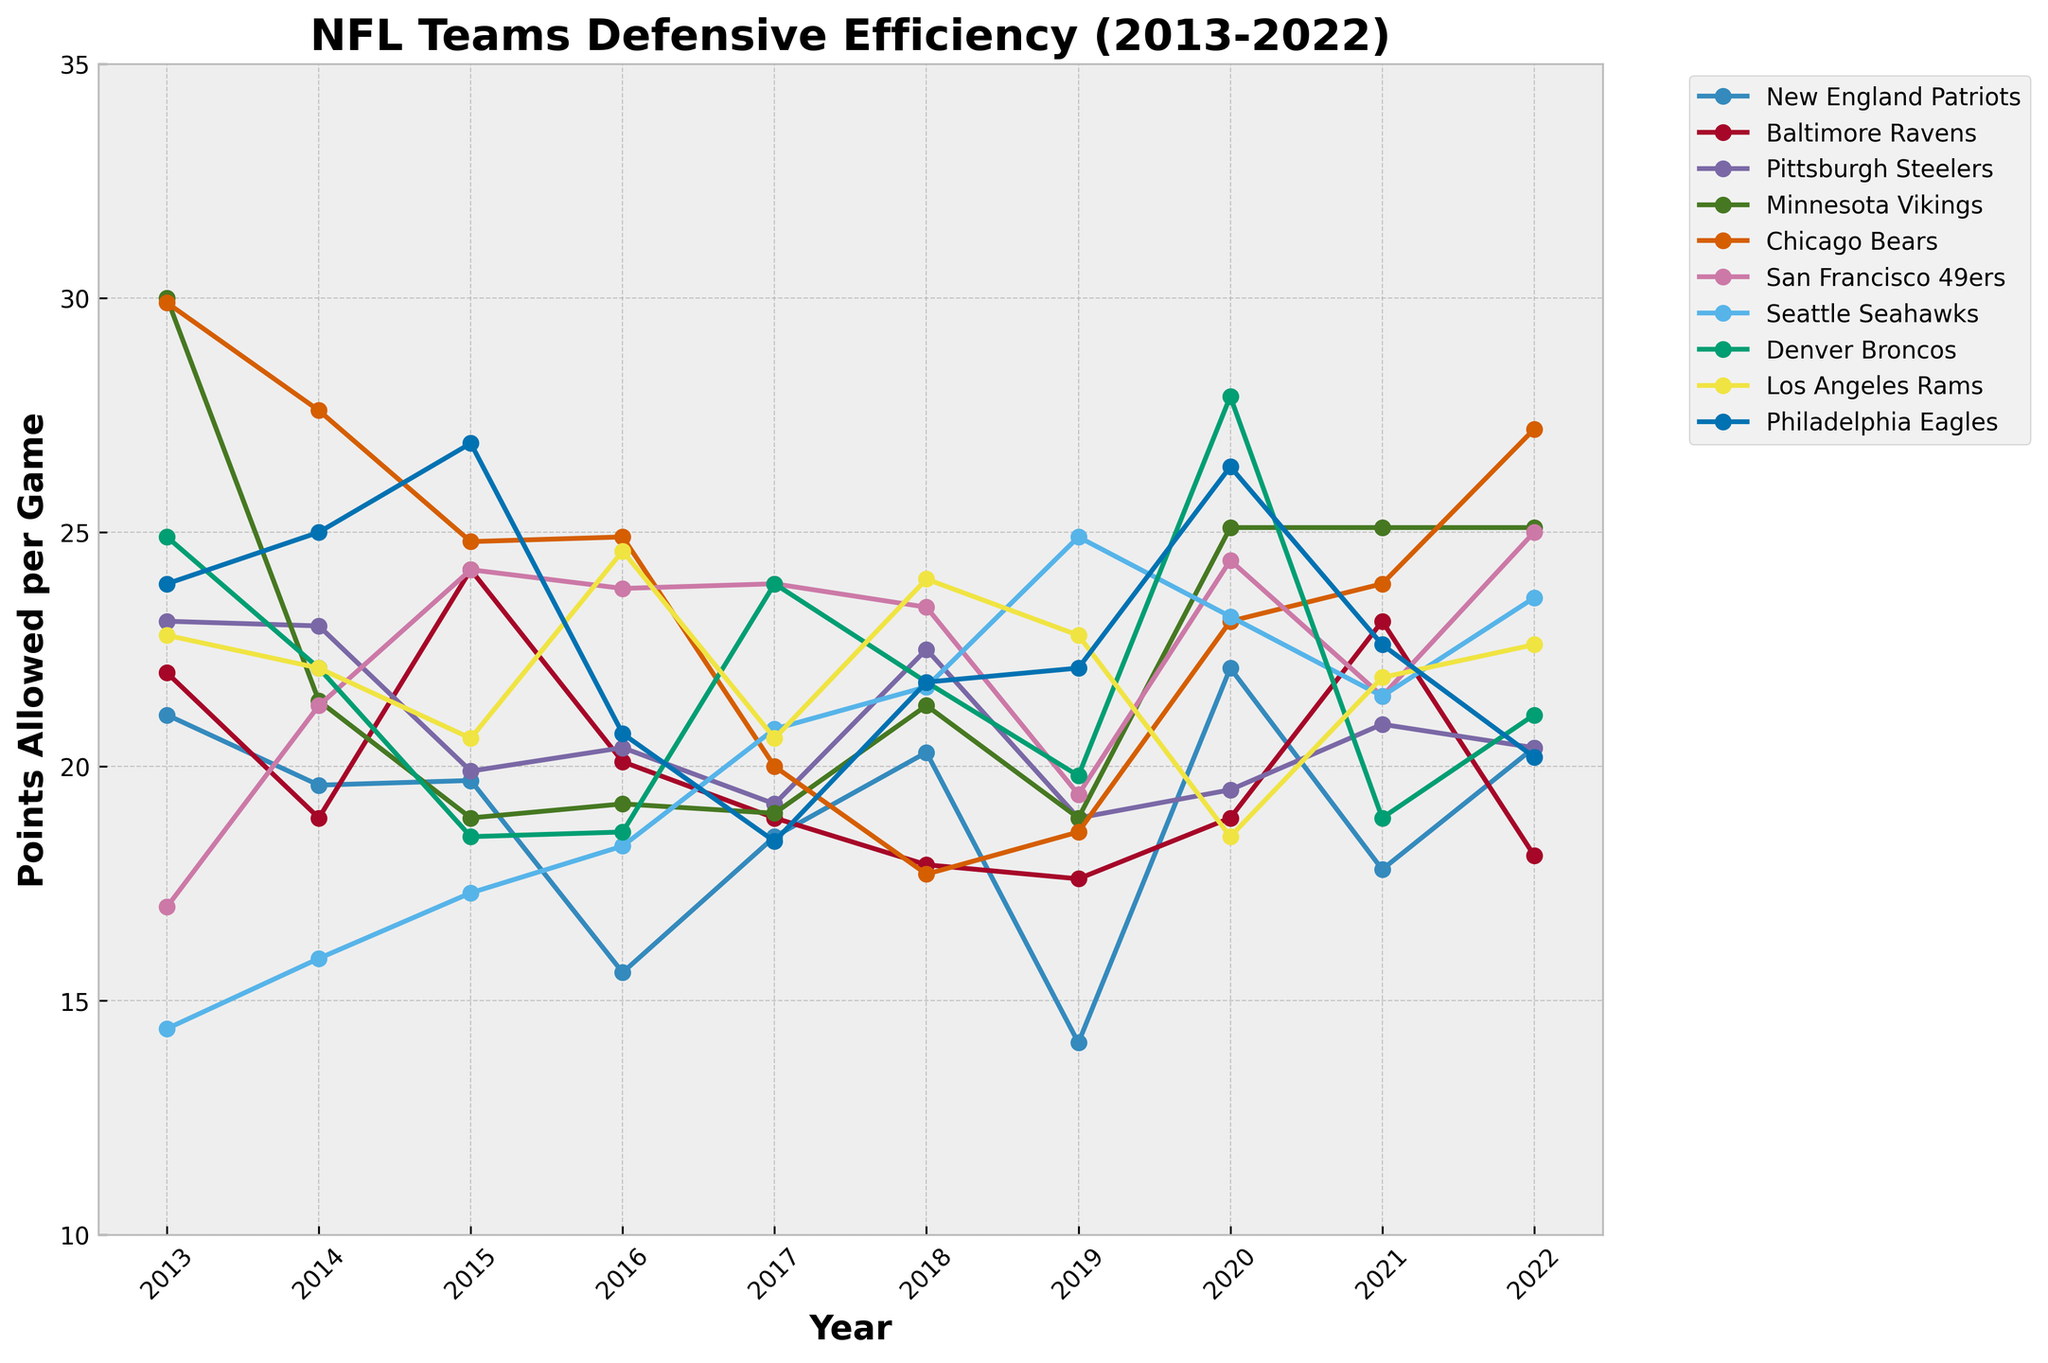Which team had the lowest points allowed per game in 2013? Look at the data for 2013 and compare each team's points allowed per game. The Seattle Seahawks had the lowest with 14.4 points.
Answer: Seattle Seahawks What was the average points allowed per game by the New England Patriots over the decade? Sum the points allowed per game for the New England Patriots for each year from 2013 to 2022, then divide by the number of years (10). The sum is 189 and the average is 189/10 = 18.9.
Answer: 18.9 Between the Baltimore Ravens and the San Francisco 49ers, which team had a better defensive efficiency in 2018? Compare the points allowed per game in 2018: the Baltimore Ravens (17.9) and the San Francisco 49ers (23.4). The Baltimore Ravens had a lower (better) value.
Answer: Baltimore Ravens In which year did the Chicago Bears show the most significant improvement in points allowed per game compared to the previous year? Calculate the difference in points allowed per game for the Chicago Bears between consecutive years and find the maximum decrease. From 2017 to 2018, the decrease was from 20.0 to 17.7, which is a decrease of 2.3.
Answer: 2018 For the period from 2015 to 2022, which team's defensive efficiency showed the most consistency (smallest difference between their highest and lowest points allowed per game)? Calculate the difference between the highest and lowest points allowed per game for each team from 2015 to 2022. The New England Patriots had the smallest range (22.1 - 15.6 = 6.5).
Answer: New England Patriots Which team had the worst defensive efficiency in 2020? Check the points allowed per game for each team in 2020 and identify the highest value. The Denver Broncos had the highest with 27.9 points allowed per game.
Answer: Denver Broncos How many times did the Minnesota Vikings' points allowed per game exceed 25 from 2013 to 2022? Count the number of years the Minnesota Vikings' points allowed per game were above 25. There are three instances: 2013 (30.0), 2020 (25.1), 2021 (25.4).
Answer: 3 In which year did the Philadelphia Eagles have the best defensive efficiency, and what was the points allowed per game? Find the minimum value of points allowed per game for the Philadelphia Eagles for each year. The best year was 2017 with 18.4 points allowed per game.
Answer: 2017, 18.4 Compare the defensive trend of the Los Angeles Rams and the Denver Broncos. Which team had a decreasing trend in points allowed per game from 2019 to 2021? Analyze the points allowed per game for both teams from 2019 to 2021. The Los Angeles Rams had a decreasing trend: 22.8 (2019), 18.5 (2020), 21.9 (2021), while the Denver Broncos showed no consistent decreasing trend.
Answer: Los Angeles Rams Which two teams had the closest defensive efficiency rating in 2017? Compare the points allowed per game in 2017 and find the two teams with points closest to each other. Chicago Bears and Los Angeles Rams both had 20.0 and 20.6 points allowed per game, respectively.
Answer: Chicago Bears and Los Angeles Rams 